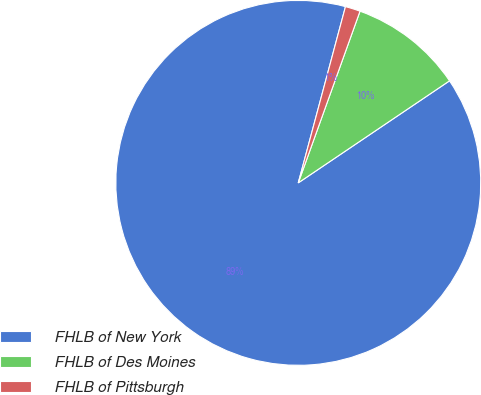Convert chart. <chart><loc_0><loc_0><loc_500><loc_500><pie_chart><fcel>FHLB of New York<fcel>FHLB of Des Moines<fcel>FHLB of Pittsburgh<nl><fcel>88.61%<fcel>10.06%<fcel>1.33%<nl></chart> 